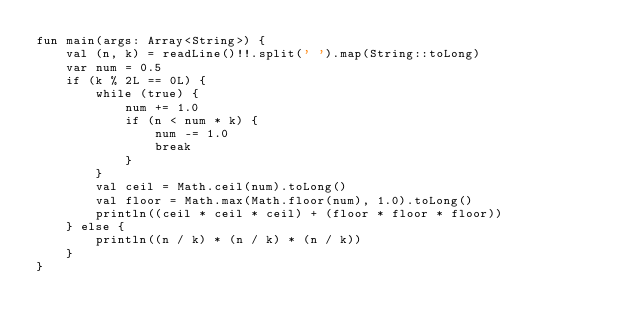Convert code to text. <code><loc_0><loc_0><loc_500><loc_500><_Kotlin_>fun main(args: Array<String>) {
    val (n, k) = readLine()!!.split(' ').map(String::toLong)
    var num = 0.5
    if (k % 2L == 0L) {
        while (true) {
            num += 1.0
            if (n < num * k) {
                num -= 1.0
                break
            }
        }
        val ceil = Math.ceil(num).toLong()
        val floor = Math.max(Math.floor(num), 1.0).toLong()
        println((ceil * ceil * ceil) + (floor * floor * floor))
    } else {
        println((n / k) * (n / k) * (n / k))
    }
}</code> 